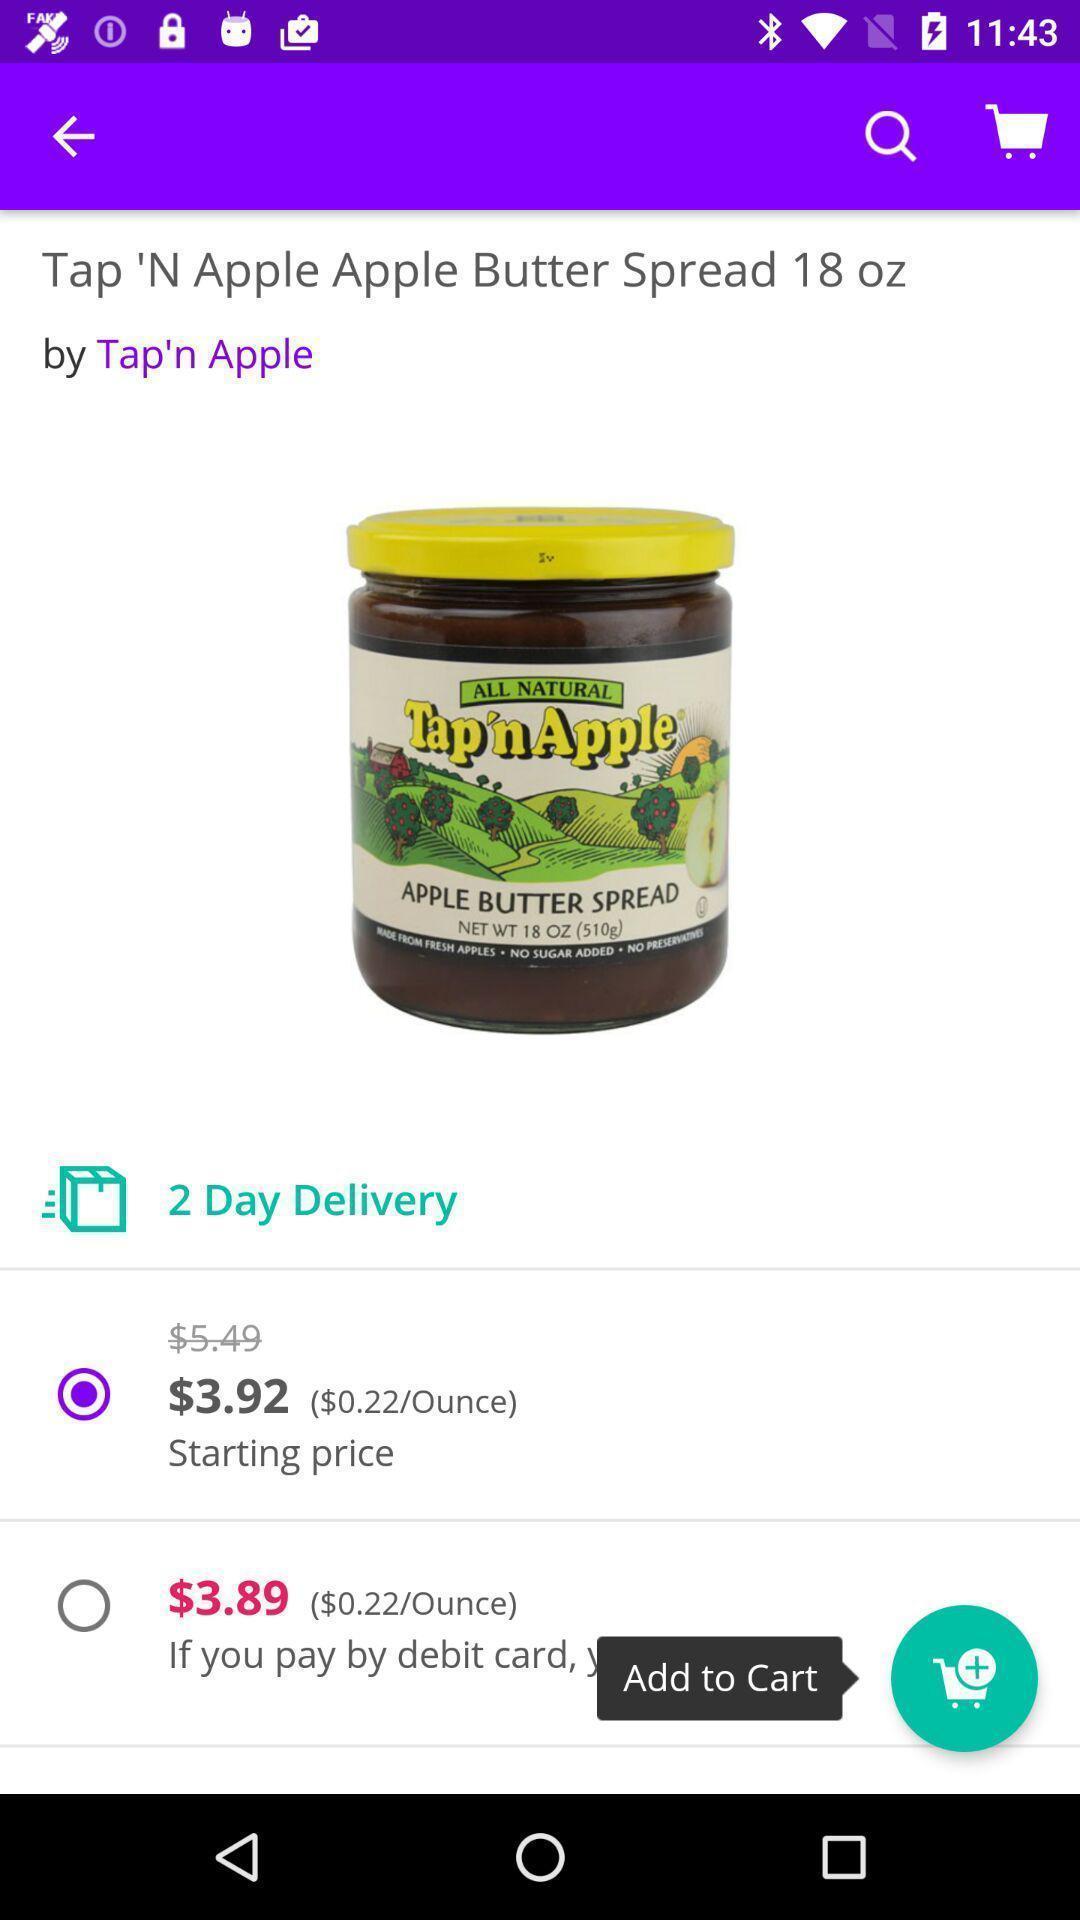Give me a summary of this screen capture. Screen displaying the product with price. 